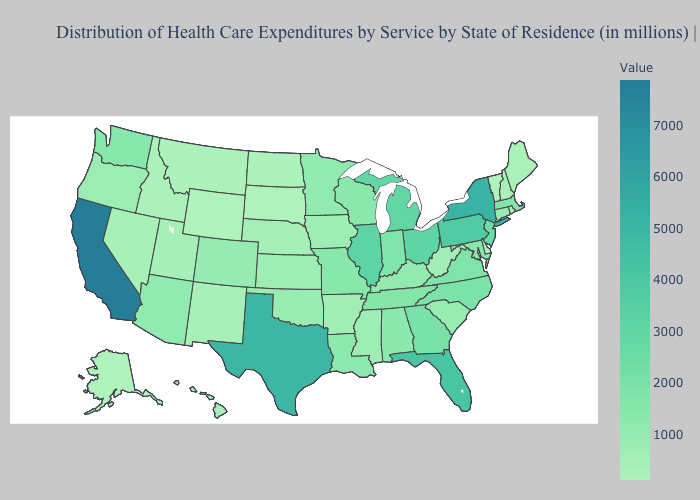Does the map have missing data?
Quick response, please. No. Does California have the highest value in the USA?
Write a very short answer. Yes. Does Arizona have the lowest value in the West?
Quick response, please. No. Among the states that border Colorado , does Arizona have the lowest value?
Answer briefly. No. Which states have the highest value in the USA?
Give a very brief answer. California. Does Wyoming have the lowest value in the USA?
Answer briefly. Yes. Does Montana have a lower value than Indiana?
Give a very brief answer. Yes. 